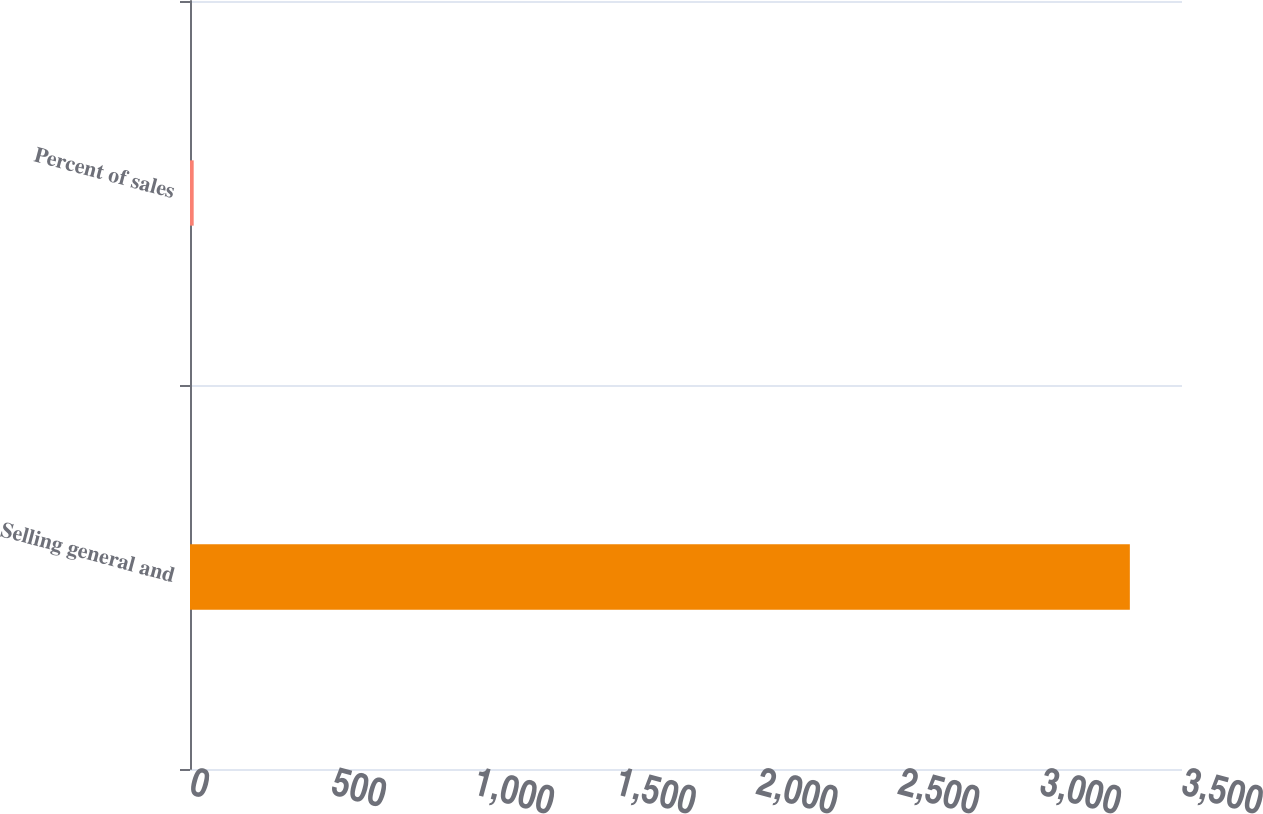<chart> <loc_0><loc_0><loc_500><loc_500><bar_chart><fcel>Selling general and<fcel>Percent of sales<nl><fcel>3316<fcel>13<nl></chart> 